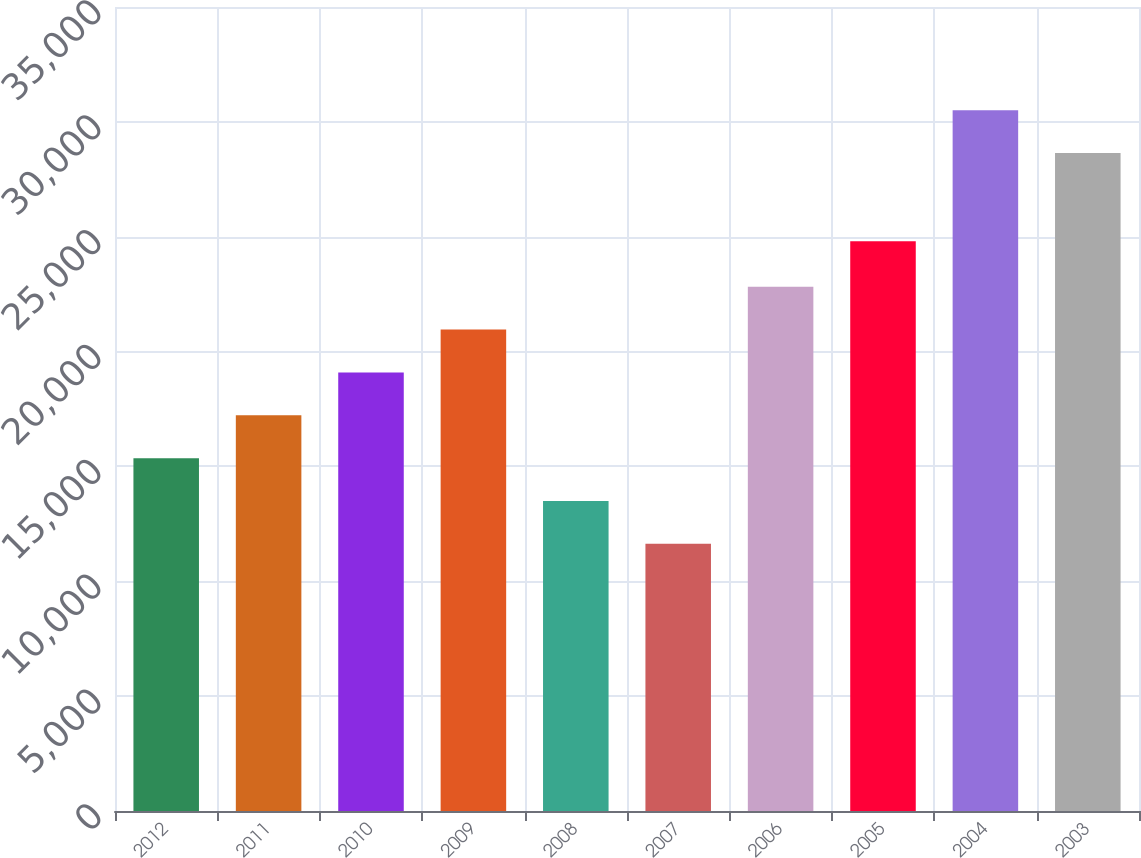<chart> <loc_0><loc_0><loc_500><loc_500><bar_chart><fcel>2012<fcel>2011<fcel>2010<fcel>2009<fcel>2008<fcel>2007<fcel>2006<fcel>2005<fcel>2004<fcel>2003<nl><fcel>15360.4<fcel>17225.6<fcel>19090.8<fcel>20956<fcel>13495.2<fcel>11630<fcel>22821.2<fcel>24806<fcel>30505.2<fcel>28640<nl></chart> 